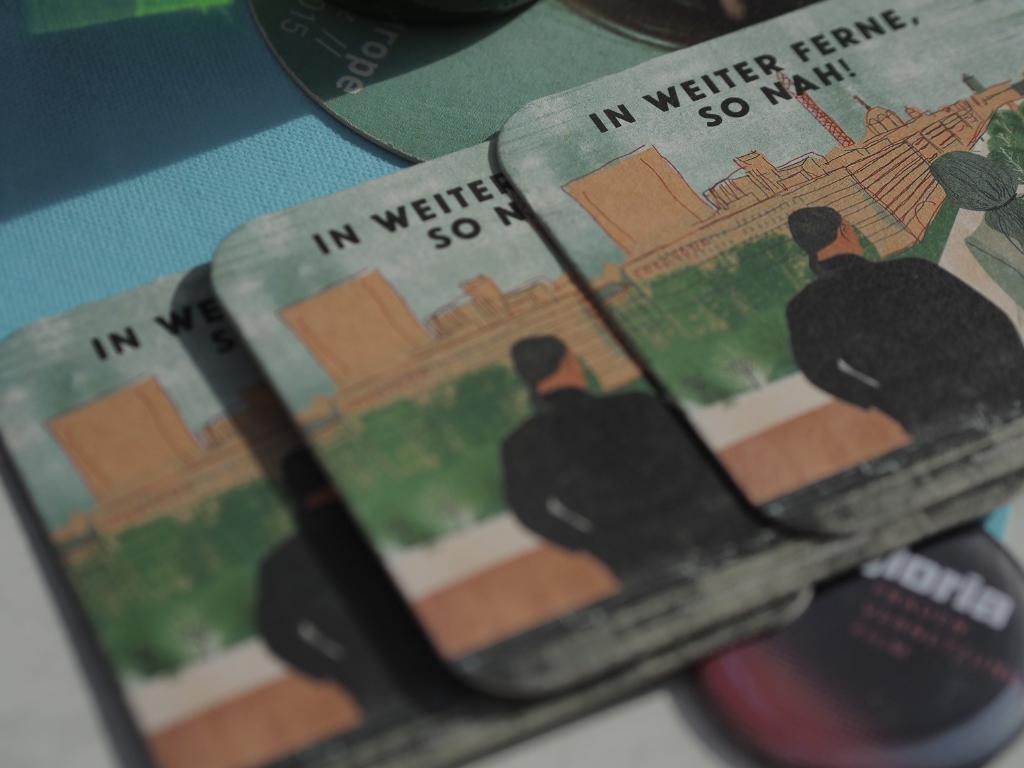What can be seen in the image? There are objects in the image. Can you describe any text that is present in the image? Yes, there is text written on the image. What is the name of the toy featured in the image? There is no toy present in the image, so it is not possible to determine its name. 